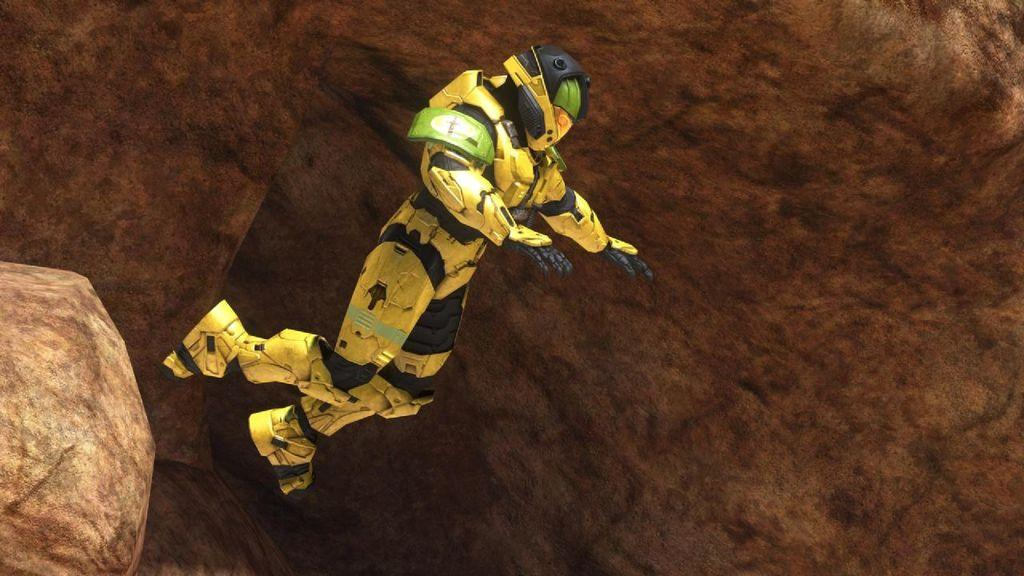Who or what is in the image? There is a person in the image. What is the person doing in the image? The person is in the air. What protective gear is the person wearing? The person is wearing a helmet. What color is the person's costume? The person is wearing a yellow costume. What can be seen in the background of the image? There are rocks in the background of the image. What type of jewel is the person holding in the image? There is no jewel present in the image; the person is wearing a yellow costume and a helmet. 